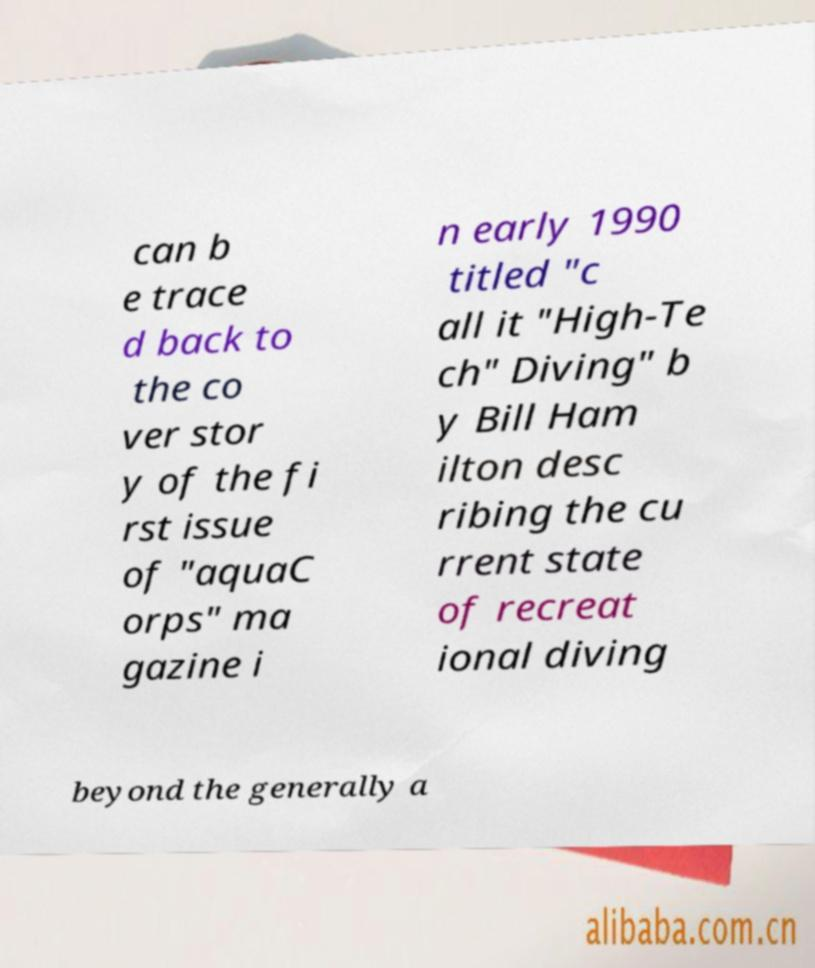Can you read and provide the text displayed in the image?This photo seems to have some interesting text. Can you extract and type it out for me? can b e trace d back to the co ver stor y of the fi rst issue of "aquaC orps" ma gazine i n early 1990 titled "c all it "High-Te ch" Diving" b y Bill Ham ilton desc ribing the cu rrent state of recreat ional diving beyond the generally a 